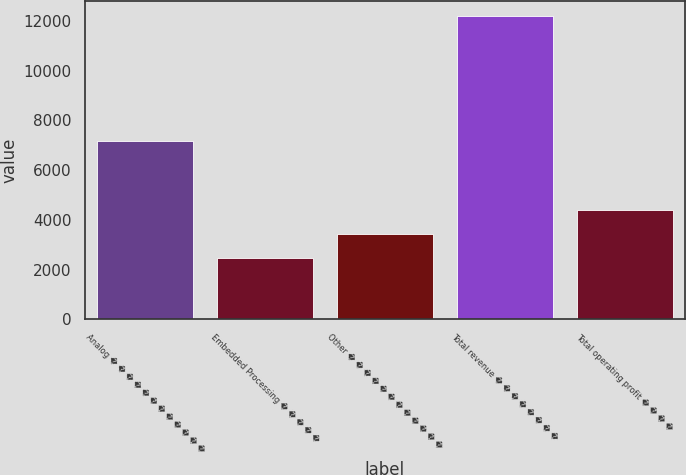<chart> <loc_0><loc_0><loc_500><loc_500><bar_chart><fcel>Analog � � � � � � � � � � � �<fcel>Embedded Processing � � � � �<fcel>Other � � � � � � � � � � � �<fcel>Total revenue � � � � � � � �<fcel>Total operating profit � � � �<nl><fcel>7194<fcel>2450<fcel>3425.5<fcel>12205<fcel>4401<nl></chart> 